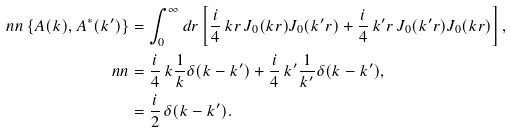<formula> <loc_0><loc_0><loc_500><loc_500>\ n n \left \{ A ( k ) , A ^ { \ast } ( k ^ { \prime } ) \right \} & = \int ^ { \infty } _ { 0 } d r \left [ \frac { i } { 4 } \, k r \, J _ { 0 } ( k r ) J _ { 0 } ( k ^ { \prime } r ) + \frac { i } { 4 } \, k ^ { \prime } r \, J _ { 0 } ( k ^ { \prime } r ) J _ { 0 } ( k r ) \right ] , \\ \ n n & = \frac { i } { 4 } \, k \frac { 1 } { k } \delta ( k - k ^ { \prime } ) + \frac { i } { 4 } \, k ^ { \prime } \frac { 1 } { k ^ { \prime } } \delta ( k - k ^ { \prime } ) , \\ & = \frac { i } { 2 } \, \delta ( k - k ^ { \prime } ) .</formula> 